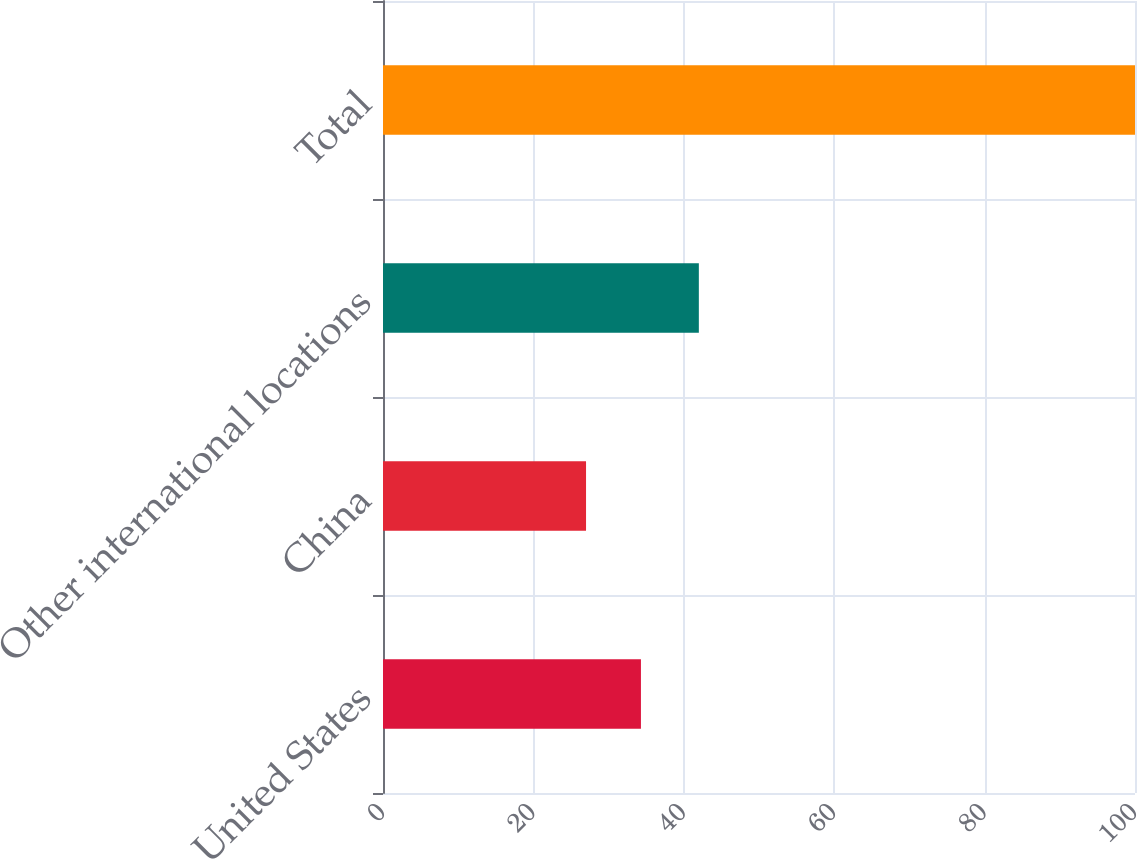Convert chart. <chart><loc_0><loc_0><loc_500><loc_500><bar_chart><fcel>United States<fcel>China<fcel>Other international locations<fcel>Total<nl><fcel>34.3<fcel>27<fcel>42<fcel>100<nl></chart> 